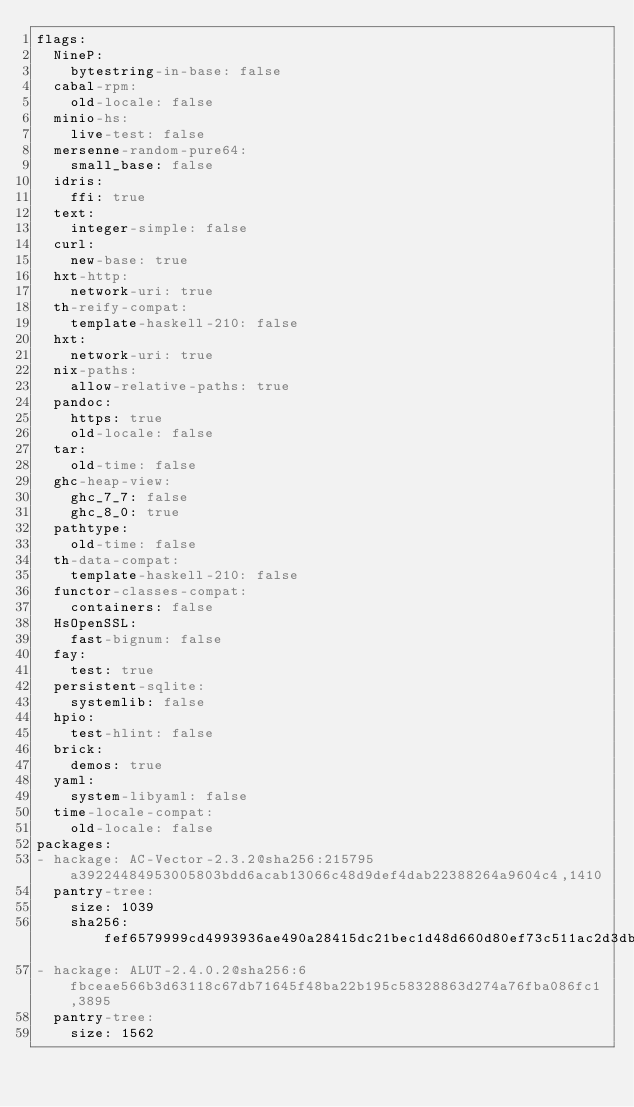Convert code to text. <code><loc_0><loc_0><loc_500><loc_500><_YAML_>flags:
  NineP:
    bytestring-in-base: false
  cabal-rpm:
    old-locale: false
  minio-hs:
    live-test: false
  mersenne-random-pure64:
    small_base: false
  idris:
    ffi: true
  text:
    integer-simple: false
  curl:
    new-base: true
  hxt-http:
    network-uri: true
  th-reify-compat:
    template-haskell-210: false
  hxt:
    network-uri: true
  nix-paths:
    allow-relative-paths: true
  pandoc:
    https: true
    old-locale: false
  tar:
    old-time: false
  ghc-heap-view:
    ghc_7_7: false
    ghc_8_0: true
  pathtype:
    old-time: false
  th-data-compat:
    template-haskell-210: false
  functor-classes-compat:
    containers: false
  HsOpenSSL:
    fast-bignum: false
  fay:
    test: true
  persistent-sqlite:
    systemlib: false
  hpio:
    test-hlint: false
  brick:
    demos: true
  yaml:
    system-libyaml: false
  time-locale-compat:
    old-locale: false
packages:
- hackage: AC-Vector-2.3.2@sha256:215795a39224484953005803bdd6acab13066c48d9def4dab22388264a9604c4,1410
  pantry-tree:
    size: 1039
    sha256: fef6579999cd4993936ae490a28415dc21bec1d48d660d80ef73c511ac2d3db2
- hackage: ALUT-2.4.0.2@sha256:6fbceae566b3d63118c67db71645f48ba22b195c58328863d274a76fba086fc1,3895
  pantry-tree:
    size: 1562</code> 